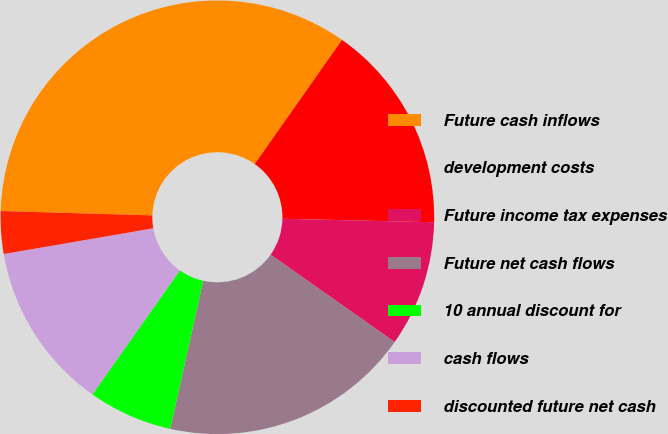<chart> <loc_0><loc_0><loc_500><loc_500><pie_chart><fcel>Future cash inflows<fcel>development costs<fcel>Future income tax expenses<fcel>Future net cash flows<fcel>10 annual discount for<fcel>cash flows<fcel>discounted future net cash<nl><fcel>34.29%<fcel>15.62%<fcel>9.4%<fcel>18.73%<fcel>6.29%<fcel>12.51%<fcel>3.17%<nl></chart> 